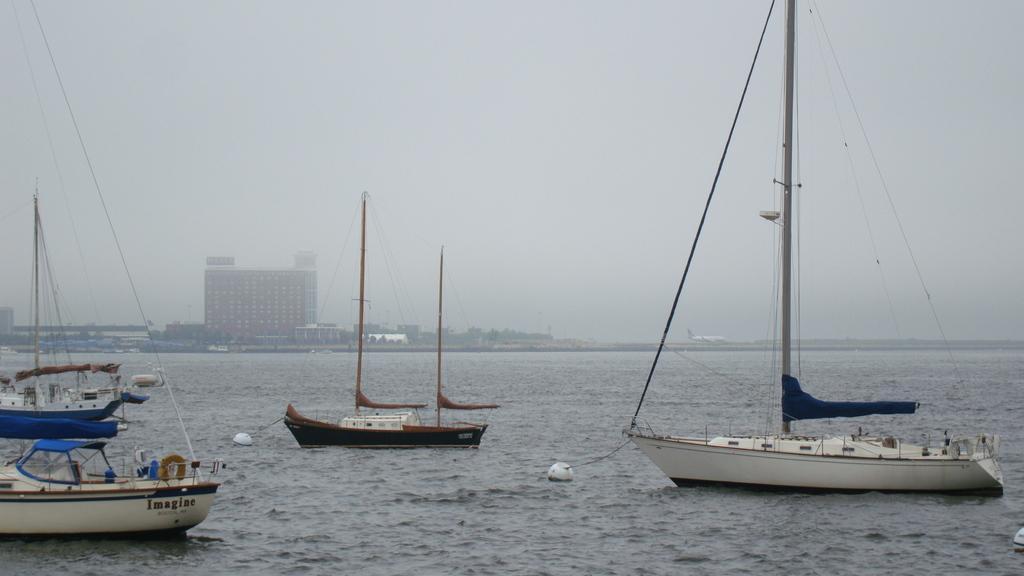How would you summarize this image in a sentence or two? In this image I can see water and in it I can see few boats. On few boats I can see something is written. In the background I can see number of buildings, an airplane and here I can see few poles and few wires. I can also see few white colour things in water. 